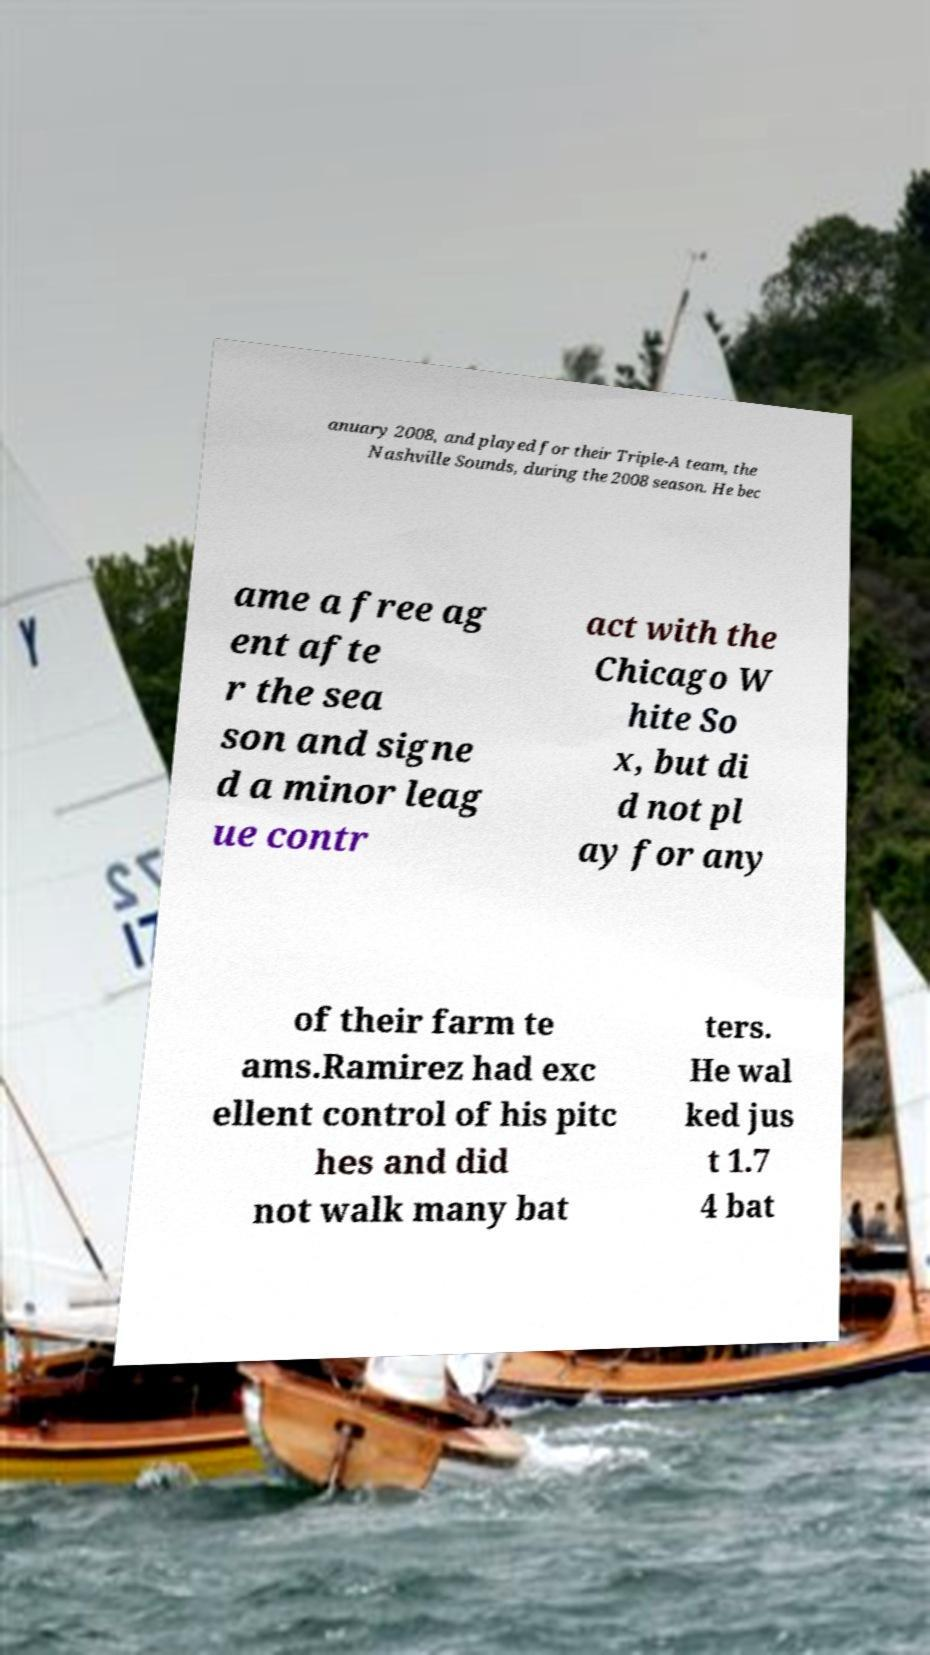There's text embedded in this image that I need extracted. Can you transcribe it verbatim? anuary 2008, and played for their Triple-A team, the Nashville Sounds, during the 2008 season. He bec ame a free ag ent afte r the sea son and signe d a minor leag ue contr act with the Chicago W hite So x, but di d not pl ay for any of their farm te ams.Ramirez had exc ellent control of his pitc hes and did not walk many bat ters. He wal ked jus t 1.7 4 bat 